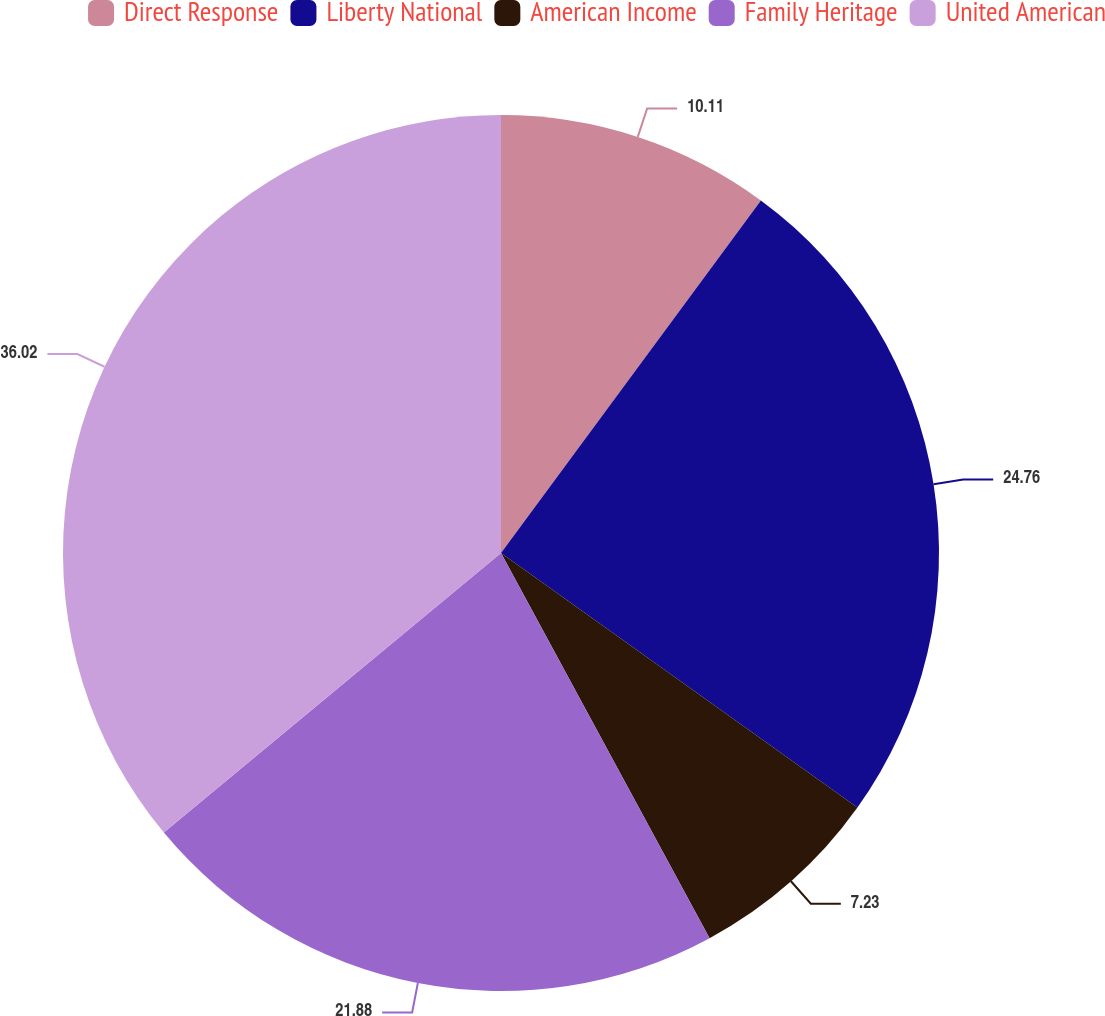Convert chart to OTSL. <chart><loc_0><loc_0><loc_500><loc_500><pie_chart><fcel>Direct Response<fcel>Liberty National<fcel>American Income<fcel>Family Heritage<fcel>United American<nl><fcel>10.11%<fcel>24.76%<fcel>7.23%<fcel>21.88%<fcel>36.02%<nl></chart> 